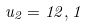<formula> <loc_0><loc_0><loc_500><loc_500>u _ { 2 } = 1 2 , 1</formula> 